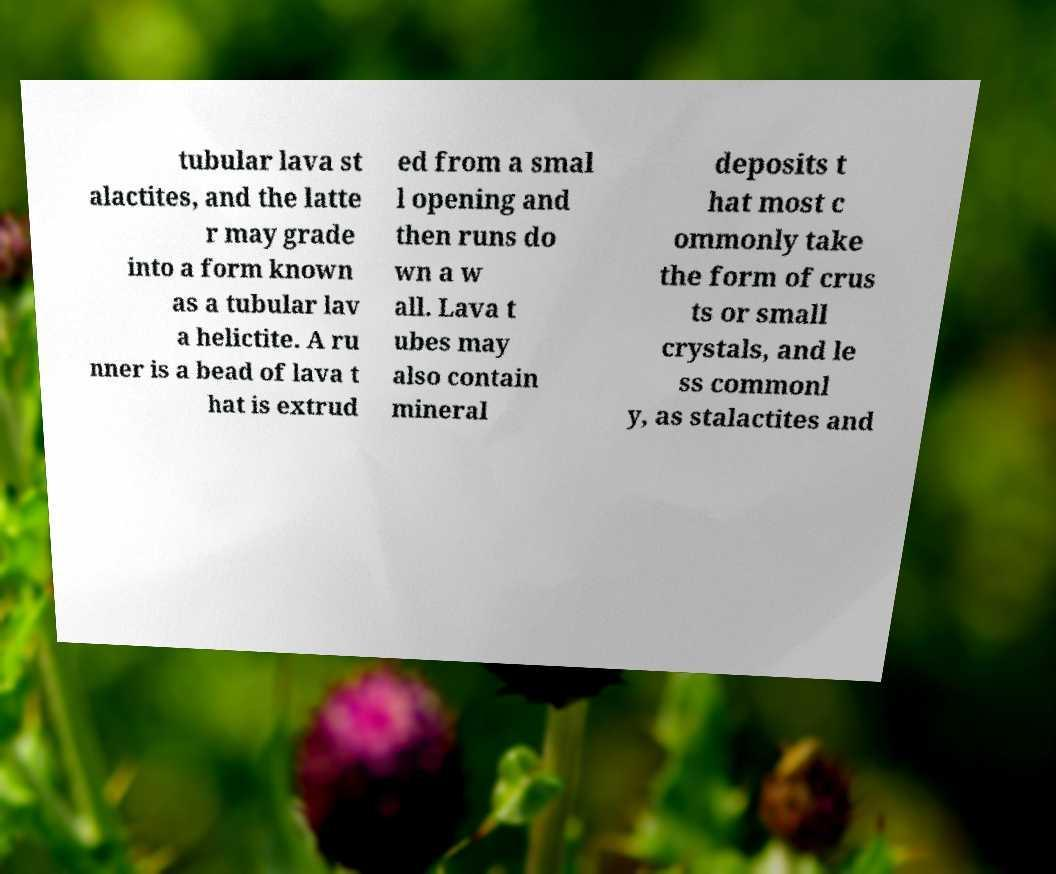Can you accurately transcribe the text from the provided image for me? tubular lava st alactites, and the latte r may grade into a form known as a tubular lav a helictite. A ru nner is a bead of lava t hat is extrud ed from a smal l opening and then runs do wn a w all. Lava t ubes may also contain mineral deposits t hat most c ommonly take the form of crus ts or small crystals, and le ss commonl y, as stalactites and 